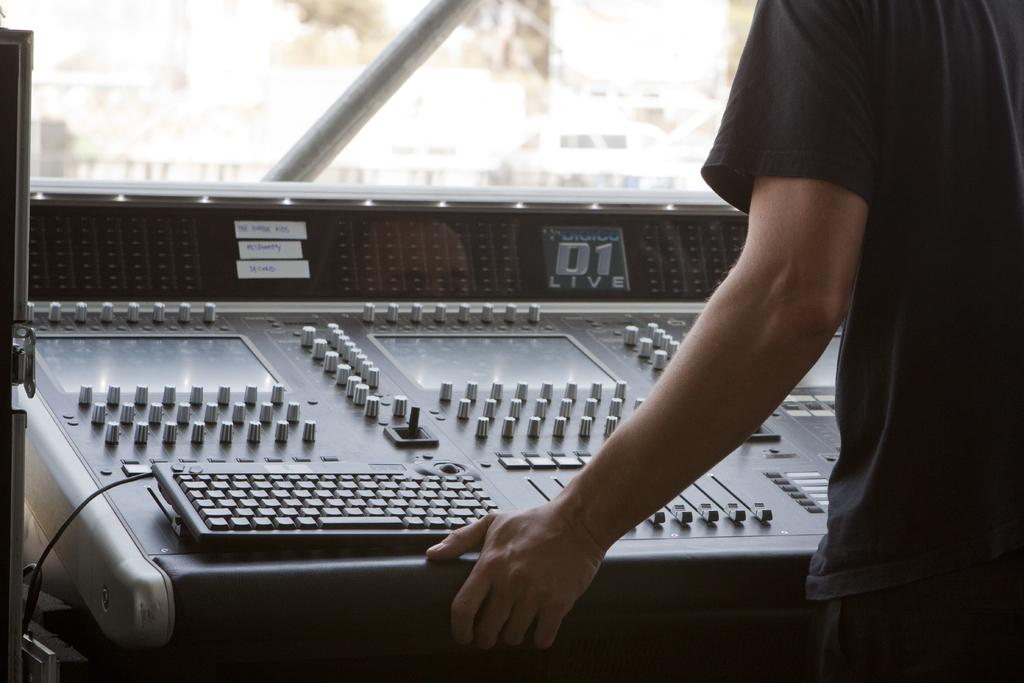Who or what is on the right side of the image? There is a person on the right side of the image. What is the person interacting with in the image? The person is interacting with a keyboard and an electronic device in front of them. What can be seen at the top of the image? There is a glass visible at the top of the image. What type of soap is the person using to clean the yarn in the image? There is no soap or yarn present in the image; it features a person interacting with a keyboard and an electronic device. 